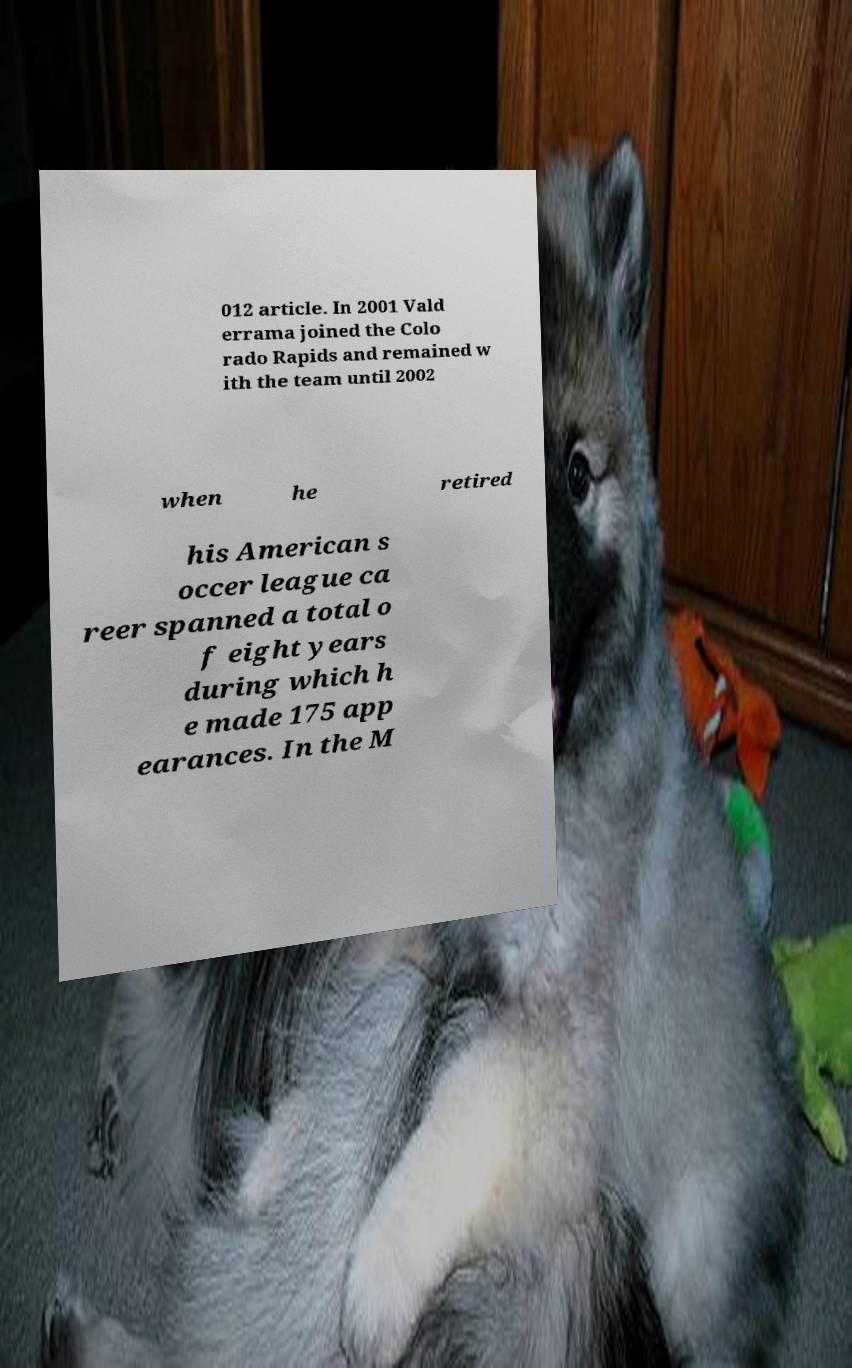For documentation purposes, I need the text within this image transcribed. Could you provide that? 012 article. In 2001 Vald errama joined the Colo rado Rapids and remained w ith the team until 2002 when he retired his American s occer league ca reer spanned a total o f eight years during which h e made 175 app earances. In the M 